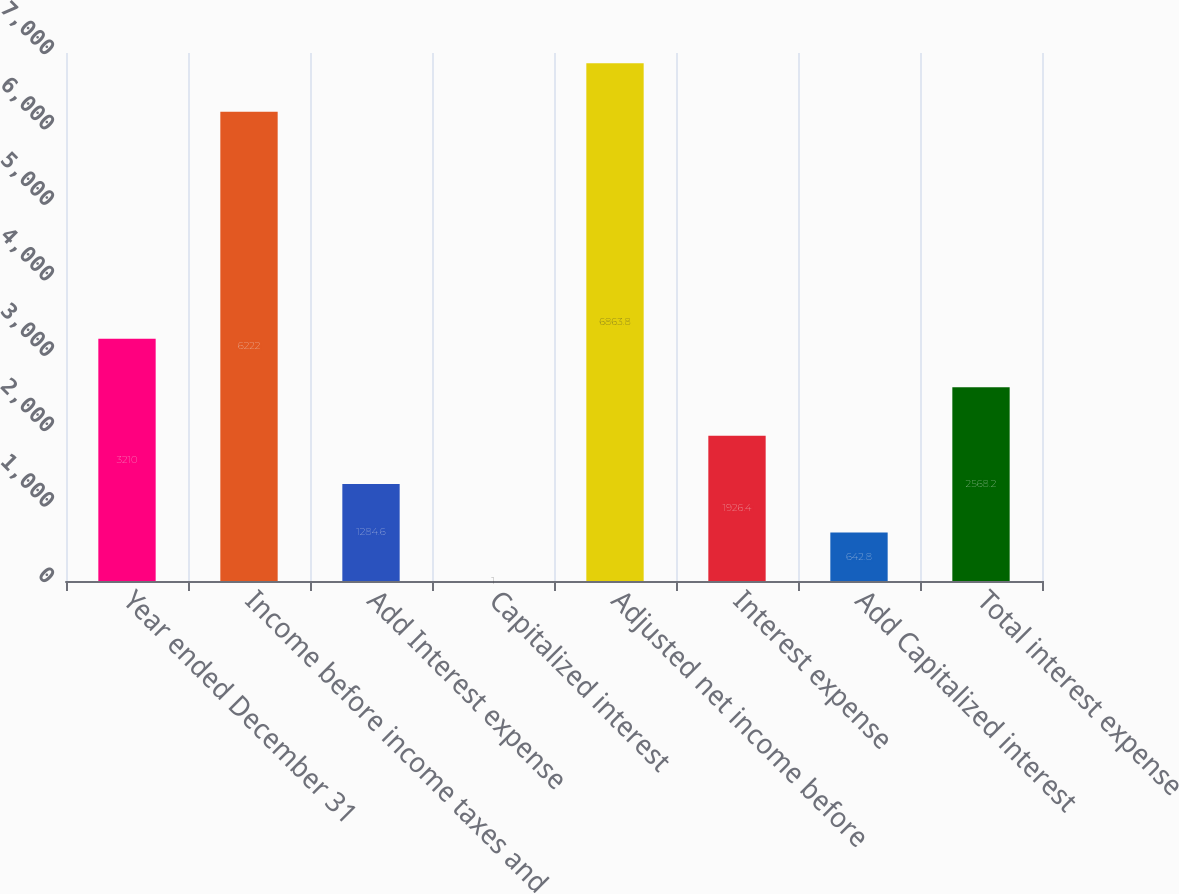Convert chart to OTSL. <chart><loc_0><loc_0><loc_500><loc_500><bar_chart><fcel>Year ended December 31<fcel>Income before income taxes and<fcel>Add Interest expense<fcel>Capitalized interest<fcel>Adjusted net income before<fcel>Interest expense<fcel>Add Capitalized interest<fcel>Total interest expense<nl><fcel>3210<fcel>6222<fcel>1284.6<fcel>1<fcel>6863.8<fcel>1926.4<fcel>642.8<fcel>2568.2<nl></chart> 